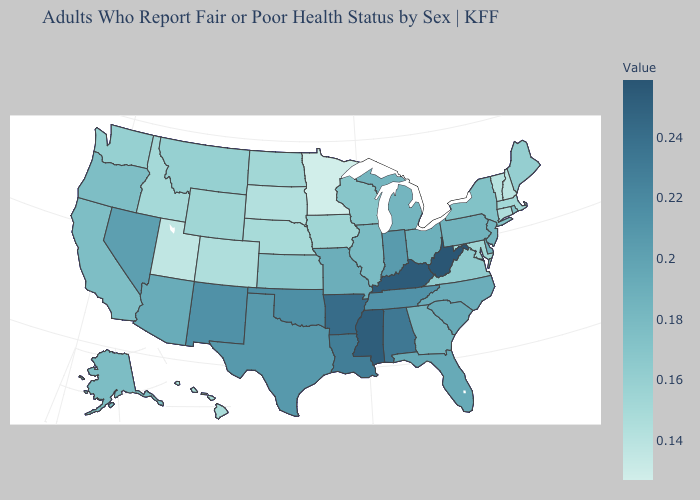Does West Virginia have the highest value in the USA?
Give a very brief answer. Yes. Which states have the lowest value in the South?
Answer briefly. Maryland. Which states have the lowest value in the USA?
Short answer required. Minnesota. Does the map have missing data?
Write a very short answer. No. Which states have the lowest value in the West?
Give a very brief answer. Utah. 